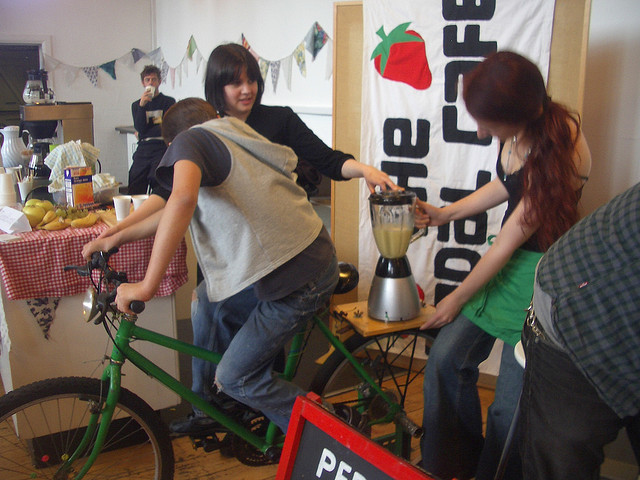<image>How many spokes are on the rear bike wheel? It is unknown how many spokes are on the rear bike wheel. It could be any number. How many spokes are on the rear bike wheel? It is unanswerable how many spokes are on the rear bike wheel. 